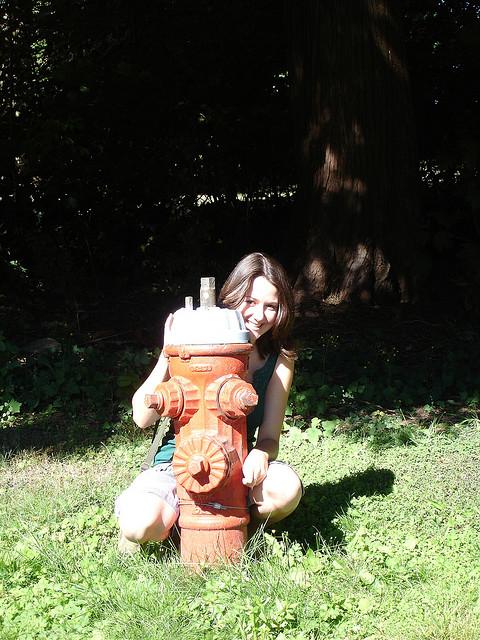Is it sunny?
Be succinct. Yes. Is this person in motion?
Keep it brief. No. What do dogs usually do to hydrant?
Be succinct. Pee. What is the sex of the person behind the fire hydrant?
Short answer required. Female. 